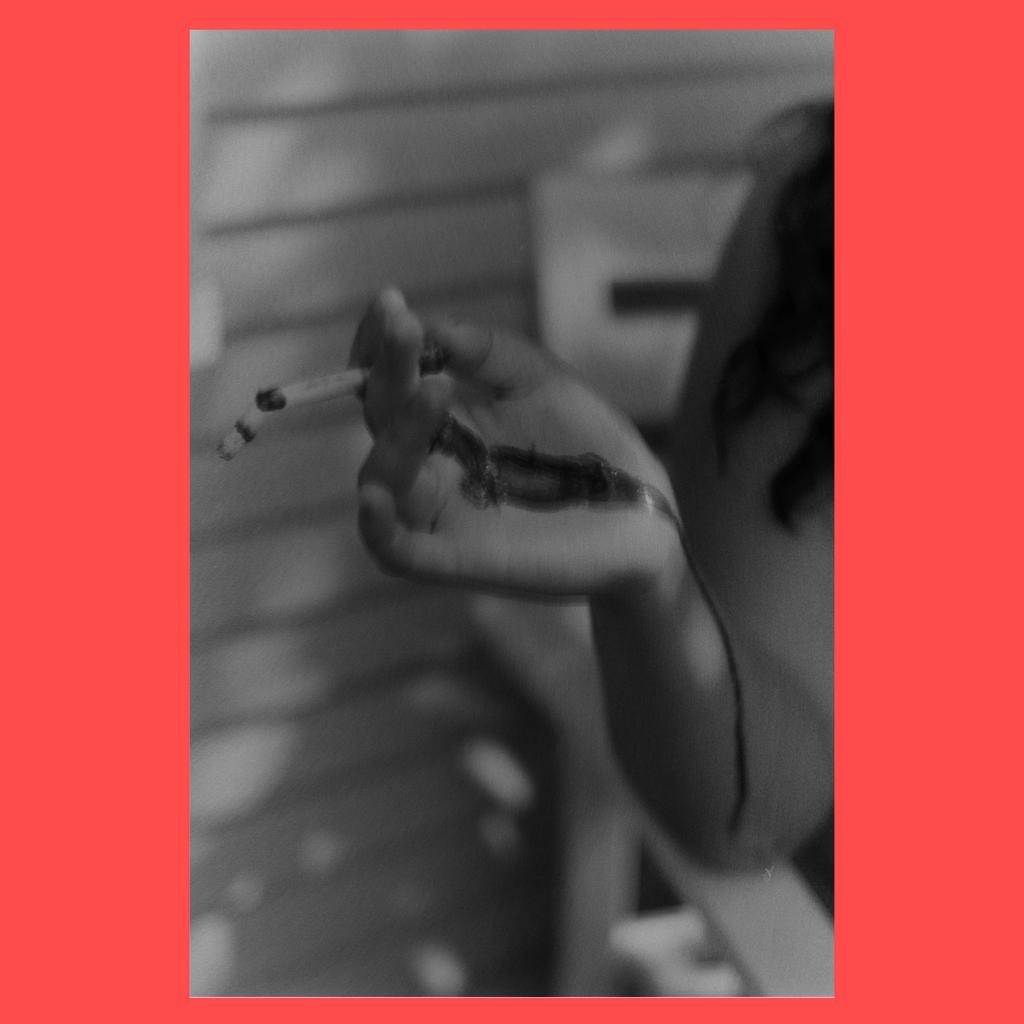What is the main subject of the image? There is a person sitting on a chair in the image. What is the person holding in their hand? The person is holding a cigarette in their hand. What color is the background of the image? The background of the image is in red color. Is the person holding an umbrella in the image? No, the person is not holding an umbrella in the image; they are holding a cigarette. 